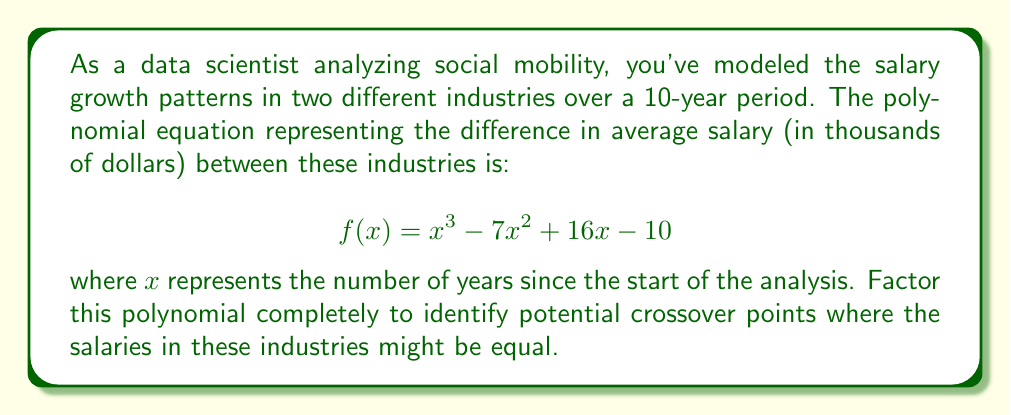Can you solve this math problem? To factor this polynomial, we'll follow these steps:

1) First, let's check if there are any rational roots using the rational root theorem. The possible rational roots are the factors of the constant term (10): ±1, ±2, ±5, ±10.

2) Testing these values, we find that $f(1) = 0$. So $(x-1)$ is a factor.

3) We can use polynomial long division to divide $f(x)$ by $(x-1)$:

   $x^3 - 7x^2 + 16x - 10 = (x-1)(x^2 - 6x + 10)$

4) Now we need to factor the quadratic term $x^2 - 6x + 10$. We can do this by finding two numbers that multiply to give 10 and add to give -6. These numbers are -2 and -4.

5) So we can factor $x^2 - 6x + 10$ as $(x-2)(x-4)$

Therefore, the complete factorization is:

$$f(x) = (x-1)(x-2)(x-4)$$

This factorization reveals that the polynomial has three real roots: 1, 2, and 4. In the context of our salary analysis, these roots represent the years where the salary difference between the two industries is zero, i.e., where the salaries are equal.
Answer: $f(x) = (x-1)(x-2)(x-4)$ 